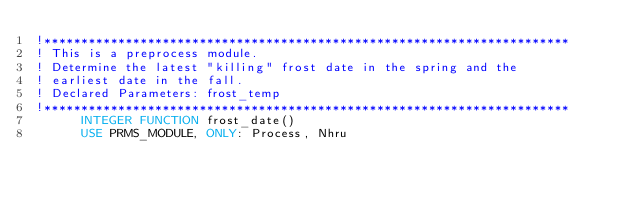<code> <loc_0><loc_0><loc_500><loc_500><_FORTRAN_>!***********************************************************************
! This is a preprocess module.
! Determine the latest "killing" frost date in the spring and the
! earliest date in the fall.
! Declared Parameters: frost_temp
!***********************************************************************
      INTEGER FUNCTION frost_date()
      USE PRMS_MODULE, ONLY: Process, Nhru</code> 